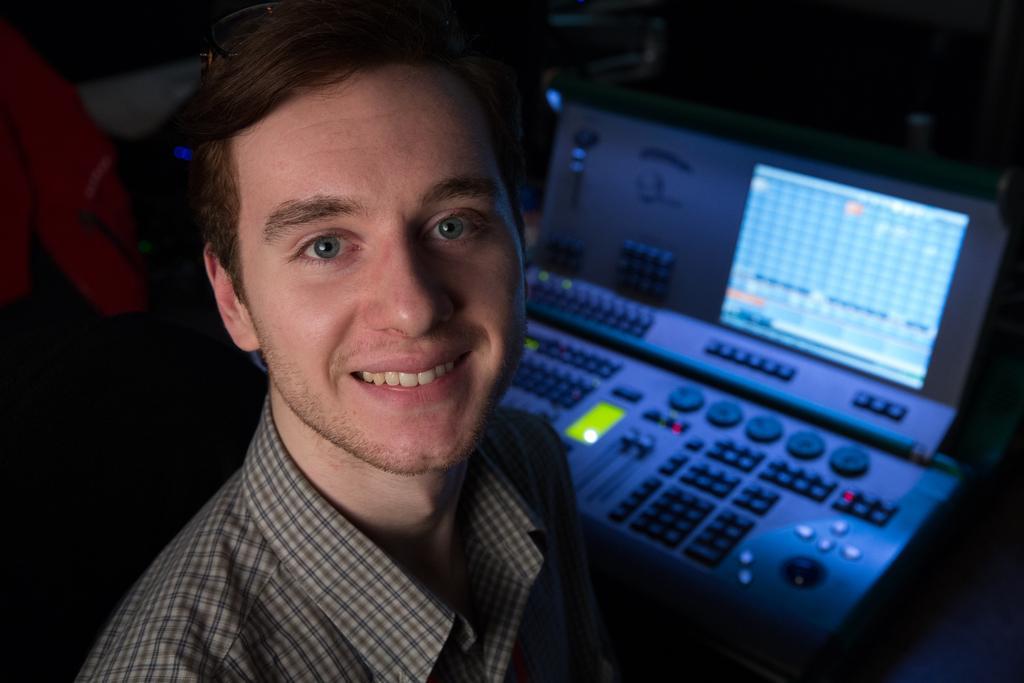How would you summarize this image in a sentence or two? In this image, I can see a person smiling. He wore a shirt. This looks like an electronic device with control buttons and a display. The background looks blurry. 